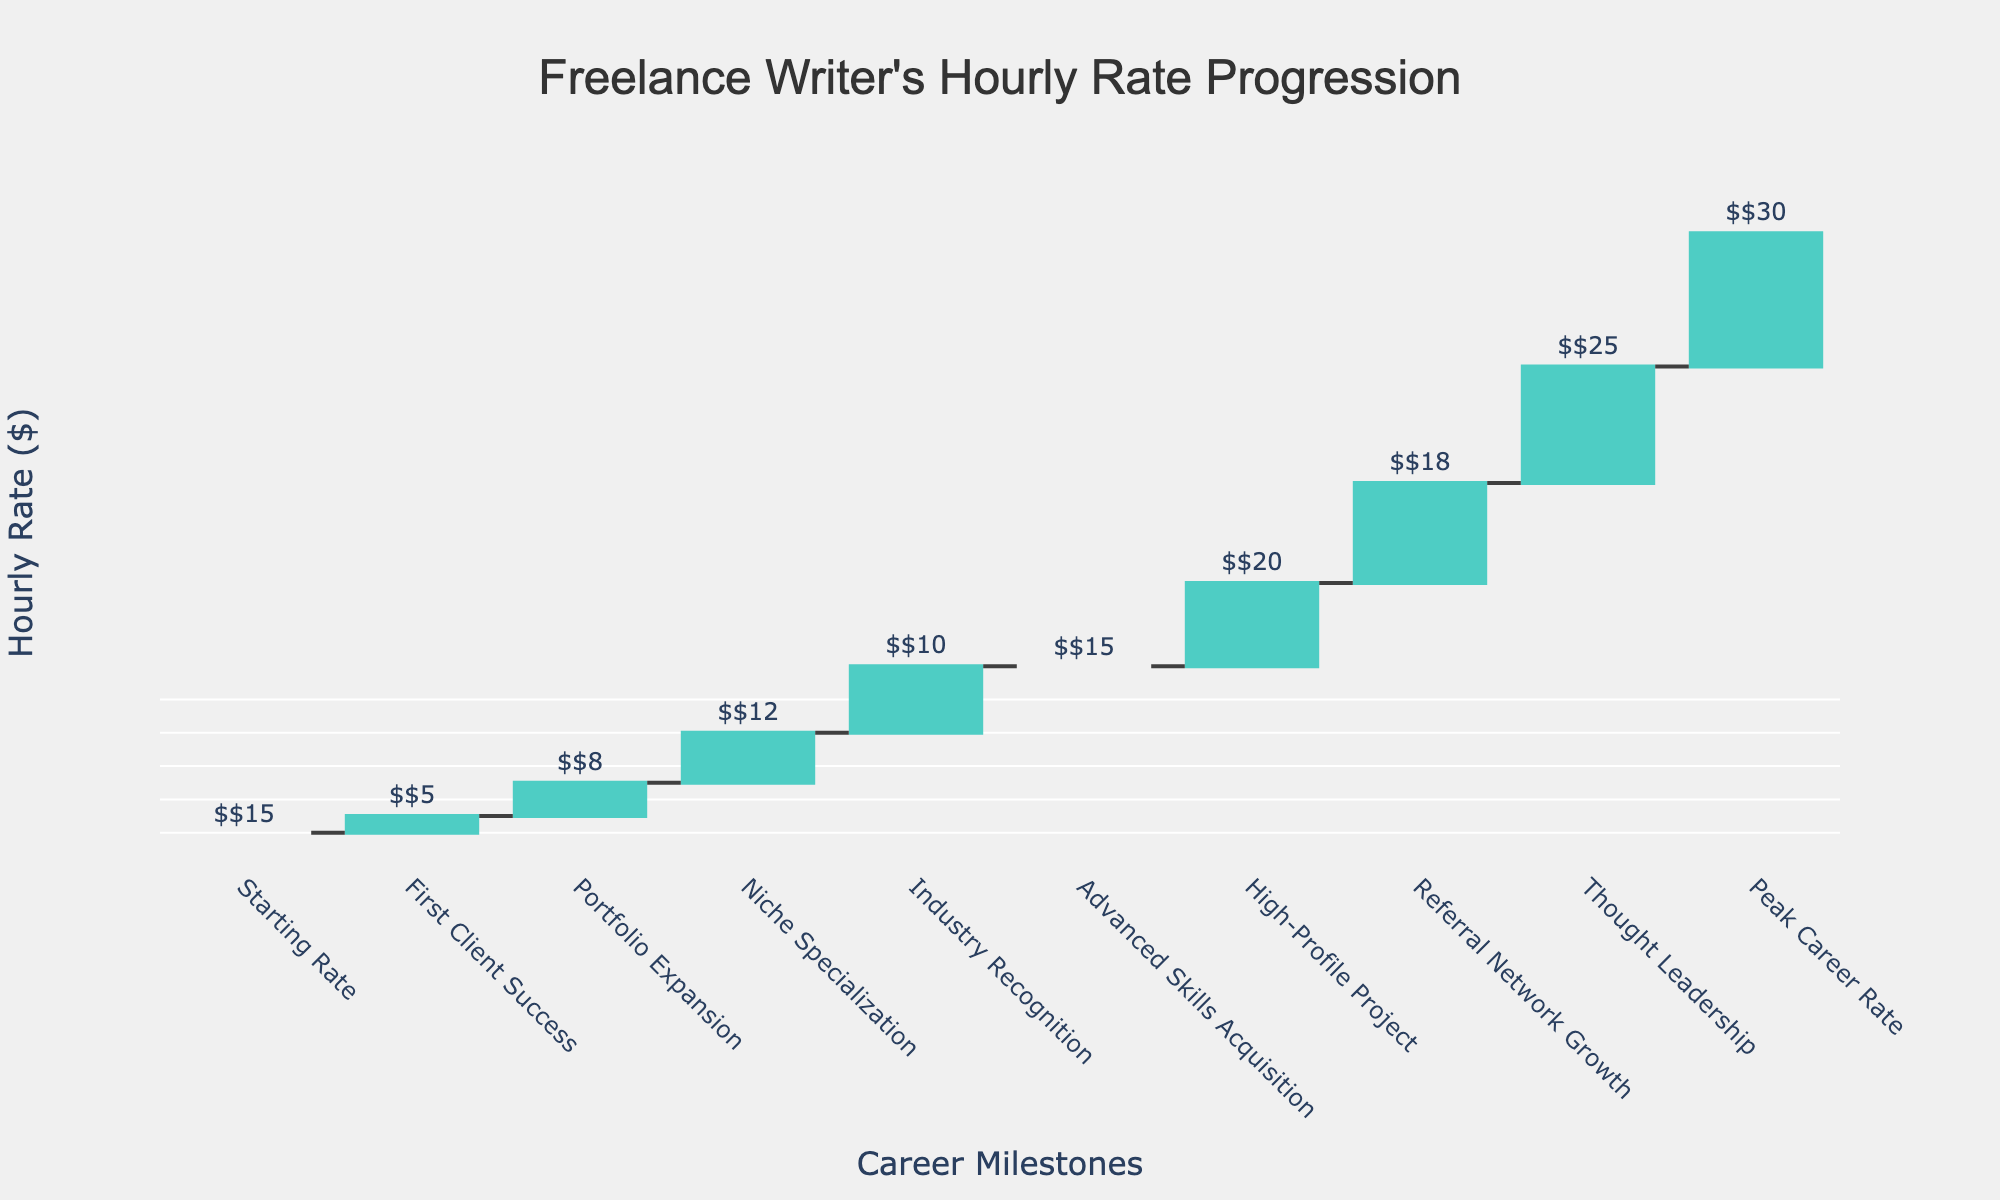What's the title of the chart? The title of the chart is displayed at the top center of the figure. It reads "Freelance Writer's Hourly Rate Progression."
Answer: Freelance Writer's Hourly Rate Progression What is the starting rate of the freelance writer? The starting rate is the first category displayed on the x-axis, labeled "Starting Rate." The value next to it explicitly states $15.
Answer: $15 How many key milestones are highlighted in the chart? Count the number of categories along the x-axis. The milestones are labeled as "Starting Rate," "First Client Success," "Portfolio Expansion," "Niche Specialization," "Industry Recognition," "Advanced Skills Acquisition," "High-Profile Project," "Referral Network Growth," "Thought Leadership," and "Peak Career Rate," totaling 10.
Answer: 10 What is the hourly rate after the freelance writer achieved "Niche Specialization"? To find the rate after "Niche Specialization," identify the accumulated value at this step. The incremental values before it are $15, $5, and $8. Adding these to the increment of $12 from "Niche Specialization" gives $15 + $5 + $8 + $12 = $40.
Answer: $40 How much did the hourly rate increase due to "Industry Recognition"? The increase caused by "Industry Recognition" can be observed from the figure. This landmark is marked with an increment of $10.
Answer: $10 What is the total increase in hourly rate from the "Starting Rate" to "Peak Career Rate"? Identify the values at "Starting Rate" ($15) and "Peak Career Rate" ($30). Subtract the starting rate from the peak rate, $30 - $15 = $15. However, notice that "Peak Career Rate" stands at $148 in cumulative sum, signifying net $133 ($148 - $15) increase.
Answer: $133 Which milestone contributed the highest value to the hourly rate? Observing the incremental values on the y-axis, "Thought Leadership" added the highest value with $25.
Answer: Thought Leadership What is the cumulative hourly rate after "Advanced Skills Acquisition"? Cumulative values up to "Advanced Skills Acquisition" are the sum of all incremental values from previous categories up to and including this step: $15 + $5 + $8 + $12 + $10 + $15 = $65.
Answer: $65 How much did the rate improve between "Referral Network Growth" and "Thought Leadership"? Comparing these milestones, "Referral Network Growth" added $18 while "Thought Leadership" added $25. So the improvement is $25 - $18 = $7.
Answer: $7 Which milestones resulted in a cumulative hourly rate exceeding $100? Check cumulative values for each milestone. "Referral Network Growth" results in exceeding $100 initially ($15 + $5 + $8 + $12 + $10 + $15 + $20 + $18 = $103). Hence, only "Referral Network Growth", and "Thought Leadership" ($128) and "Peak Career Rate" ($148) accumulate exceed $100.
Answer: Referral Network Growth, Thought Leadership, Peak Career Rate 